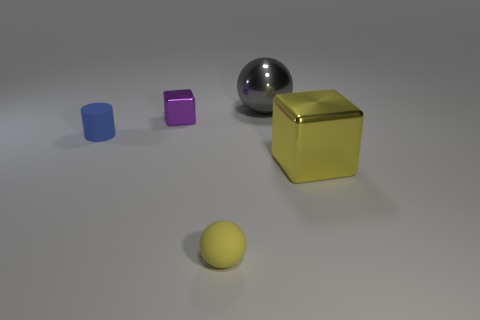Do the yellow metallic thing and the rubber sphere have the same size?
Your response must be concise. No. What material is the big yellow cube?
Ensure brevity in your answer.  Metal. There is a purple cube that is the same size as the blue matte object; what material is it?
Offer a very short reply. Metal. Are there any metal balls of the same size as the yellow metal block?
Offer a terse response. Yes. Is the number of small cubes in front of the blue matte object the same as the number of rubber cylinders behind the tiny purple shiny cube?
Offer a terse response. Yes. Are there more tiny blue cylinders than small cyan objects?
Your answer should be very brief. Yes. What number of matte things are cylinders or yellow objects?
Provide a short and direct response. 2. What number of tiny metallic blocks have the same color as the small matte ball?
Keep it short and to the point. 0. What is the yellow object that is right of the matte thing that is in front of the rubber object that is left of the yellow ball made of?
Make the answer very short. Metal. The small rubber thing that is in front of the shiny block that is on the right side of the tiny yellow thing is what color?
Your response must be concise. Yellow. 